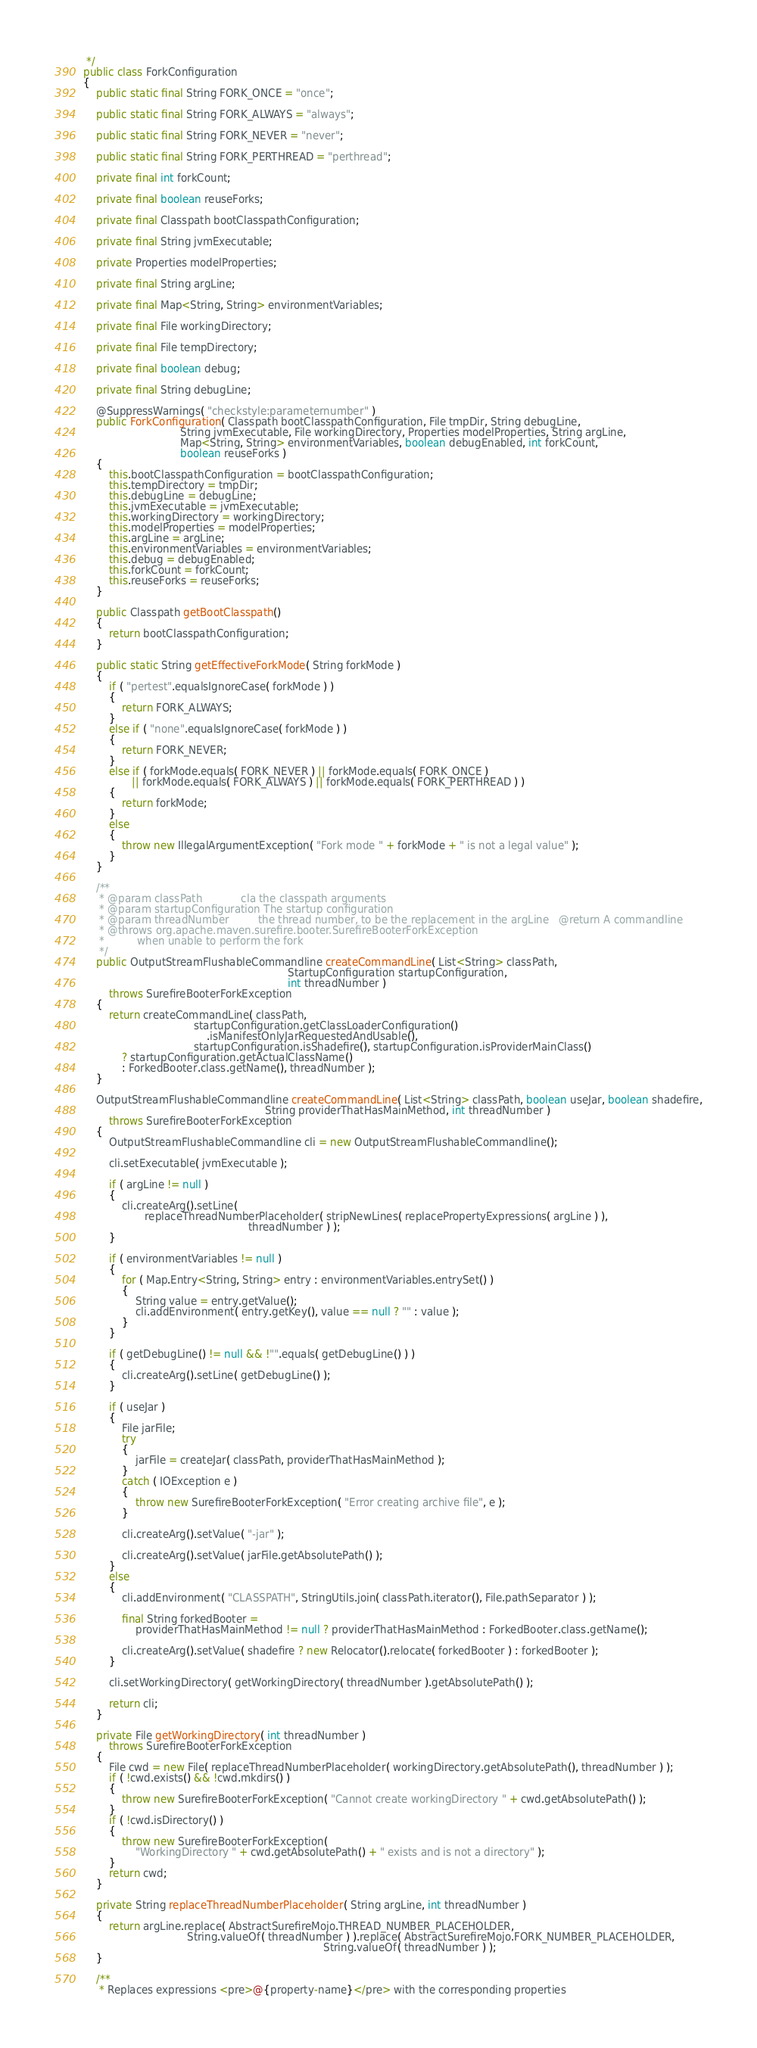<code> <loc_0><loc_0><loc_500><loc_500><_Java_> */
public class ForkConfiguration
{
    public static final String FORK_ONCE = "once";

    public static final String FORK_ALWAYS = "always";

    public static final String FORK_NEVER = "never";

    public static final String FORK_PERTHREAD = "perthread";

    private final int forkCount;

    private final boolean reuseForks;

    private final Classpath bootClasspathConfiguration;

    private final String jvmExecutable;

    private Properties modelProperties;

    private final String argLine;

    private final Map<String, String> environmentVariables;

    private final File workingDirectory;

    private final File tempDirectory;

    private final boolean debug;

    private final String debugLine;

    @SuppressWarnings( "checkstyle:parameternumber" )
    public ForkConfiguration( Classpath bootClasspathConfiguration, File tmpDir, String debugLine,
                              String jvmExecutable, File workingDirectory, Properties modelProperties, String argLine,
                              Map<String, String> environmentVariables, boolean debugEnabled, int forkCount,
                              boolean reuseForks )
    {
        this.bootClasspathConfiguration = bootClasspathConfiguration;
        this.tempDirectory = tmpDir;
        this.debugLine = debugLine;
        this.jvmExecutable = jvmExecutable;
        this.workingDirectory = workingDirectory;
        this.modelProperties = modelProperties;
        this.argLine = argLine;
        this.environmentVariables = environmentVariables;
        this.debug = debugEnabled;
        this.forkCount = forkCount;
        this.reuseForks = reuseForks;
    }

    public Classpath getBootClasspath()
    {
        return bootClasspathConfiguration;
    }

    public static String getEffectiveForkMode( String forkMode )
    {
        if ( "pertest".equalsIgnoreCase( forkMode ) )
        {
            return FORK_ALWAYS;
        }
        else if ( "none".equalsIgnoreCase( forkMode ) )
        {
            return FORK_NEVER;
        }
        else if ( forkMode.equals( FORK_NEVER ) || forkMode.equals( FORK_ONCE )
               || forkMode.equals( FORK_ALWAYS ) || forkMode.equals( FORK_PERTHREAD ) )
        {
            return forkMode;
        }
        else
        {
            throw new IllegalArgumentException( "Fork mode " + forkMode + " is not a legal value" );
        }
    }

    /**
     * @param classPath            cla the classpath arguments
     * @param startupConfiguration The startup configuration
     * @param threadNumber         the thread number, to be the replacement in the argLine   @return A commandline
     * @throws org.apache.maven.surefire.booter.SurefireBooterForkException
     *          when unable to perform the fork
     */
    public OutputStreamFlushableCommandline createCommandLine( List<String> classPath,
                                                               StartupConfiguration startupConfiguration,
                                                               int threadNumber )
        throws SurefireBooterForkException
    {
        return createCommandLine( classPath,
                                  startupConfiguration.getClassLoaderConfiguration()
                                      .isManifestOnlyJarRequestedAndUsable(),
                                  startupConfiguration.isShadefire(), startupConfiguration.isProviderMainClass()
            ? startupConfiguration.getActualClassName()
            : ForkedBooter.class.getName(), threadNumber );
    }

    OutputStreamFlushableCommandline createCommandLine( List<String> classPath, boolean useJar, boolean shadefire,
                                                        String providerThatHasMainMethod, int threadNumber )
        throws SurefireBooterForkException
    {
        OutputStreamFlushableCommandline cli = new OutputStreamFlushableCommandline();

        cli.setExecutable( jvmExecutable );

        if ( argLine != null )
        {
            cli.createArg().setLine(
                   replaceThreadNumberPlaceholder( stripNewLines( replacePropertyExpressions( argLine ) ),
                                                   threadNumber ) );
        }

        if ( environmentVariables != null )
        {
            for ( Map.Entry<String, String> entry : environmentVariables.entrySet() )
            {
                String value = entry.getValue();
                cli.addEnvironment( entry.getKey(), value == null ? "" : value );
            }
        }

        if ( getDebugLine() != null && !"".equals( getDebugLine() ) )
        {
            cli.createArg().setLine( getDebugLine() );
        }

        if ( useJar )
        {
            File jarFile;
            try
            {
                jarFile = createJar( classPath, providerThatHasMainMethod );
            }
            catch ( IOException e )
            {
                throw new SurefireBooterForkException( "Error creating archive file", e );
            }

            cli.createArg().setValue( "-jar" );

            cli.createArg().setValue( jarFile.getAbsolutePath() );
        }
        else
        {
            cli.addEnvironment( "CLASSPATH", StringUtils.join( classPath.iterator(), File.pathSeparator ) );

            final String forkedBooter =
                providerThatHasMainMethod != null ? providerThatHasMainMethod : ForkedBooter.class.getName();

            cli.createArg().setValue( shadefire ? new Relocator().relocate( forkedBooter ) : forkedBooter );
        }

        cli.setWorkingDirectory( getWorkingDirectory( threadNumber ).getAbsolutePath() );

        return cli;
    }

    private File getWorkingDirectory( int threadNumber )
        throws SurefireBooterForkException
    {
        File cwd = new File( replaceThreadNumberPlaceholder( workingDirectory.getAbsolutePath(), threadNumber ) );
        if ( !cwd.exists() && !cwd.mkdirs() )
        {
            throw new SurefireBooterForkException( "Cannot create workingDirectory " + cwd.getAbsolutePath() );
        }
        if ( !cwd.isDirectory() )
        {
            throw new SurefireBooterForkException(
                "WorkingDirectory " + cwd.getAbsolutePath() + " exists and is not a directory" );
        }
        return cwd;
    }

    private String replaceThreadNumberPlaceholder( String argLine, int threadNumber )
    {
        return argLine.replace( AbstractSurefireMojo.THREAD_NUMBER_PLACEHOLDER,
                                String.valueOf( threadNumber ) ).replace( AbstractSurefireMojo.FORK_NUMBER_PLACEHOLDER,
                                                                          String.valueOf( threadNumber ) );
    }

    /**
     * Replaces expressions <pre>@{property-name}</pre> with the corresponding properties</code> 